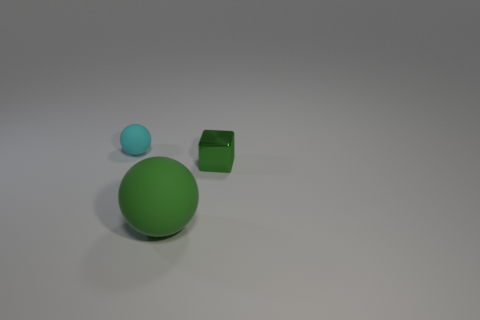What size is the thing that is both in front of the small cyan ball and to the left of the cube?
Your answer should be very brief. Large. Is there any other thing that has the same size as the green rubber object?
Offer a terse response. No. What size is the green object that is made of the same material as the cyan sphere?
Give a very brief answer. Large. Is the color of the small cube the same as the large object?
Your response must be concise. Yes. The other thing that is the same shape as the big thing is what size?
Your answer should be compact. Small. What is the material of the small block that is the same color as the large thing?
Provide a short and direct response. Metal. Do the metallic object and the green ball have the same size?
Provide a short and direct response. No. Are there any green things that are behind the big matte sphere that is in front of the tiny green shiny object?
Make the answer very short. Yes. What number of other objects are there of the same shape as the shiny thing?
Provide a succinct answer. 0. Is the shape of the big green object the same as the small rubber object?
Offer a terse response. Yes. 